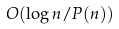Convert formula to latex. <formula><loc_0><loc_0><loc_500><loc_500>O ( \log n / P ( n ) )</formula> 